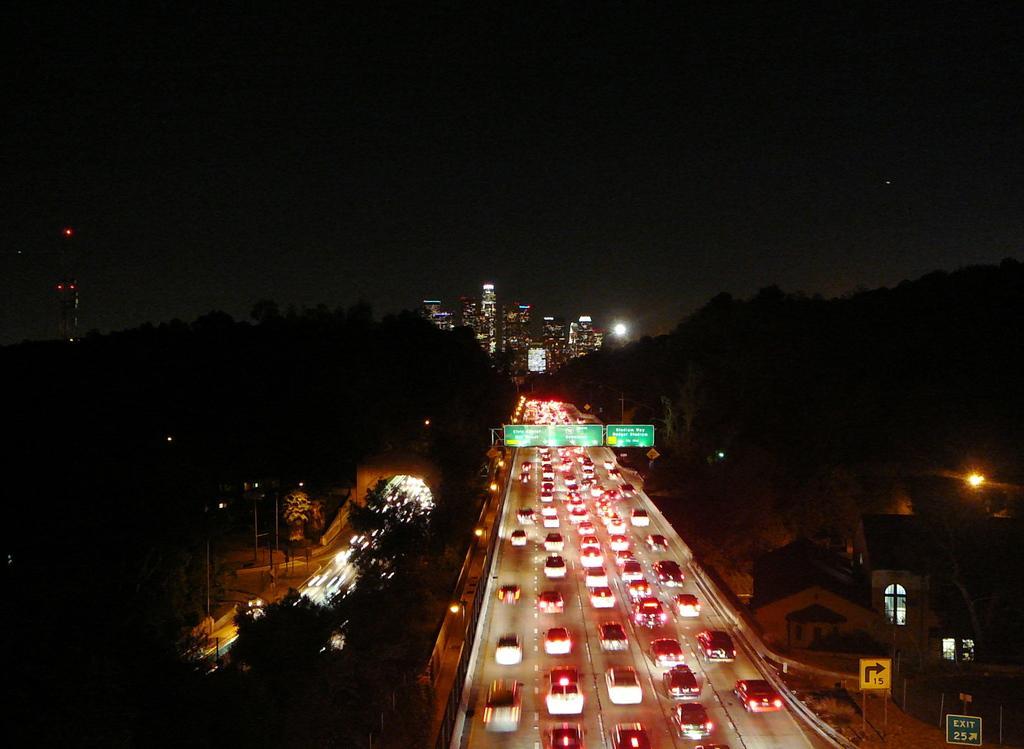In one or two sentences, can you explain what this image depicts? There are vehicles on the in the center of the image and house structures on the right side. There are trees on both the sides, there are buildings, sky and light in the background area. 